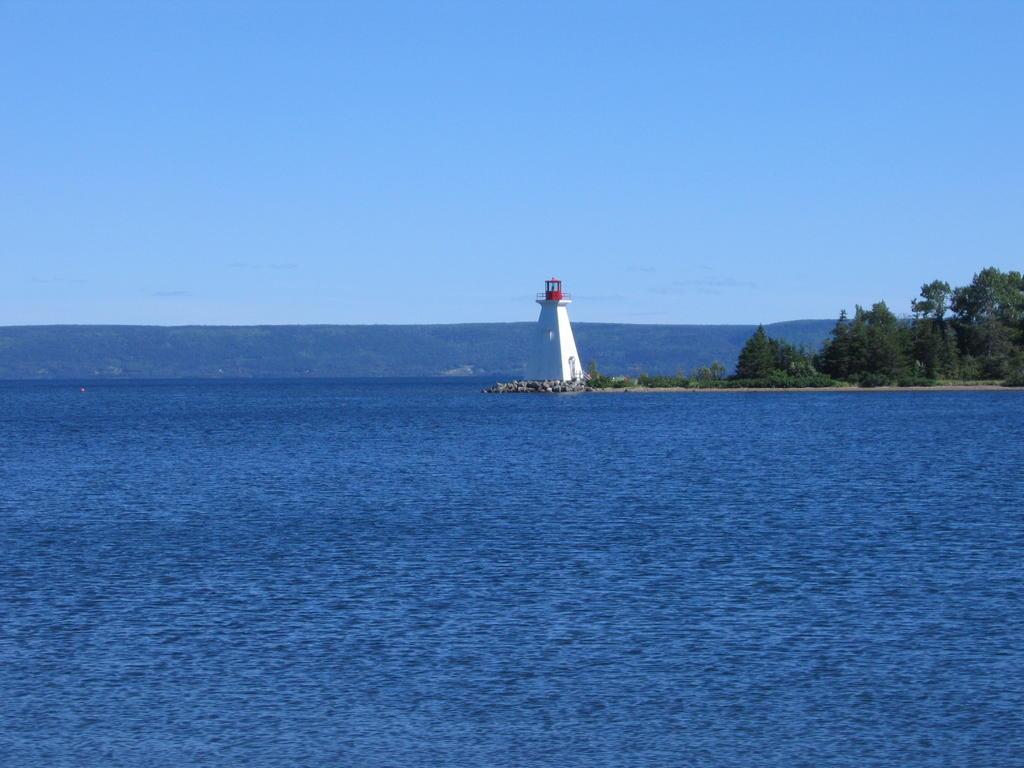Please provide a concise description of this image. This picture shows water and we see a blue sky and a tower and we see trees. 